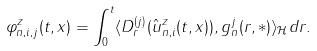Convert formula to latex. <formula><loc_0><loc_0><loc_500><loc_500>\varphi ^ { z } _ { n , i , j } ( t , x ) = \int _ { 0 } ^ { t } \langle D ^ { ( j ) } _ { r } ( \hat { u } ^ { z } _ { n , i } ( t , x ) ) , g ^ { j } _ { n } ( r , \ast ) \rangle _ { \mathcal { H } } d r .</formula> 